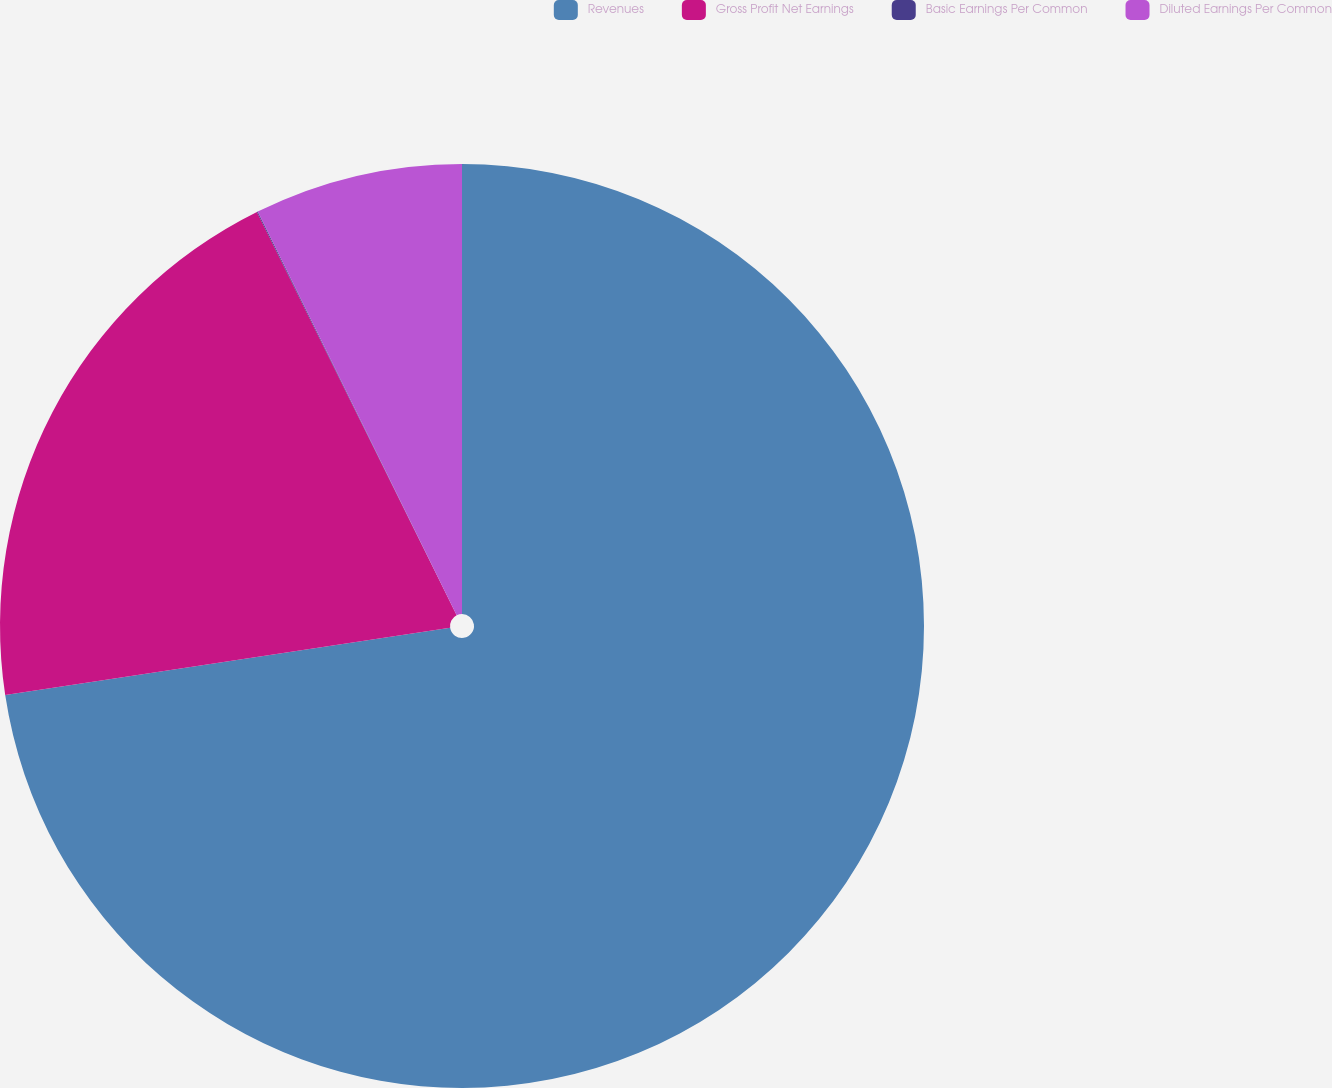Convert chart. <chart><loc_0><loc_0><loc_500><loc_500><pie_chart><fcel>Revenues<fcel>Gross Profit Net Earnings<fcel>Basic Earnings Per Common<fcel>Diluted Earnings Per Common<nl><fcel>72.61%<fcel>20.07%<fcel>0.03%<fcel>7.29%<nl></chart> 